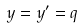<formula> <loc_0><loc_0><loc_500><loc_500>y = y ^ { \prime } = q</formula> 